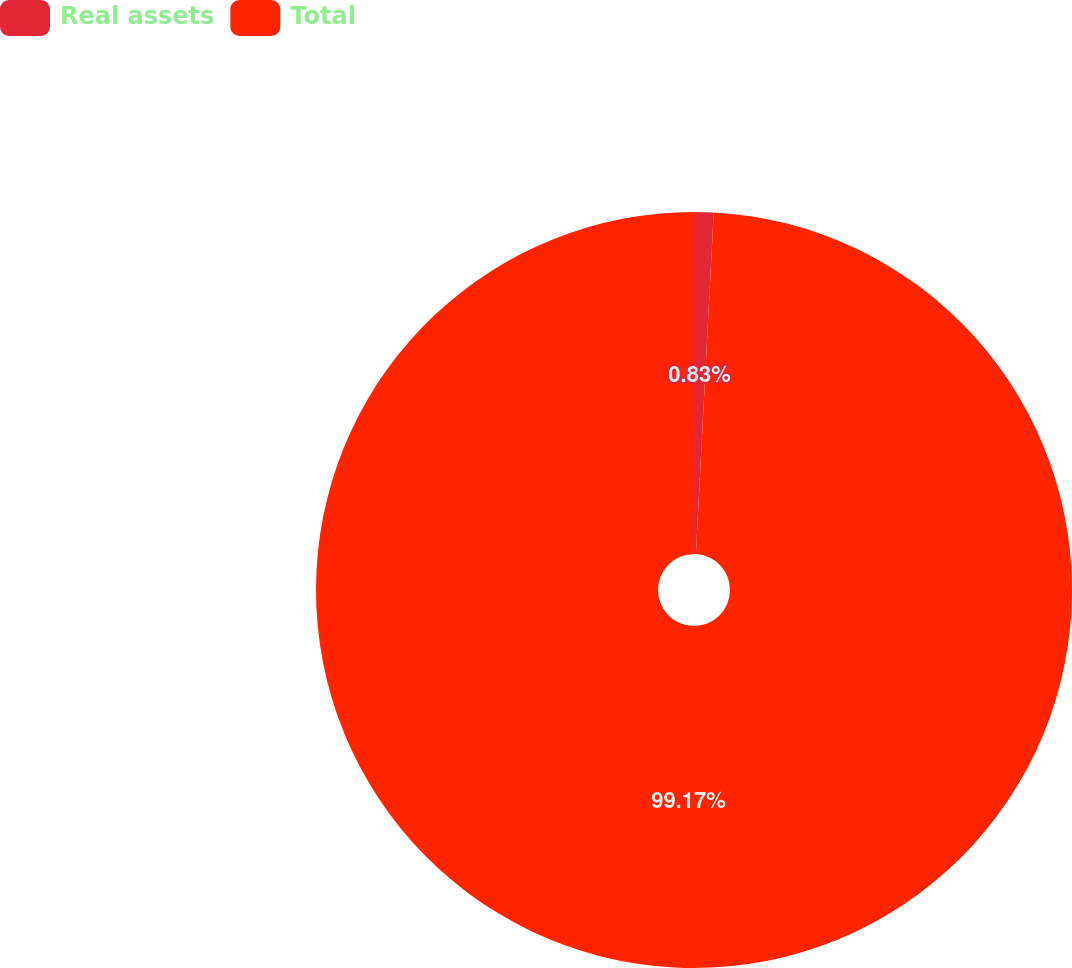Convert chart to OTSL. <chart><loc_0><loc_0><loc_500><loc_500><pie_chart><fcel>Real assets<fcel>Total<nl><fcel>0.83%<fcel>99.17%<nl></chart> 